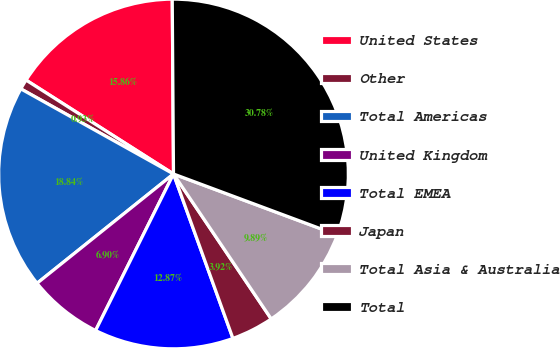Convert chart to OTSL. <chart><loc_0><loc_0><loc_500><loc_500><pie_chart><fcel>United States<fcel>Other<fcel>Total Americas<fcel>United Kingdom<fcel>Total EMEA<fcel>Japan<fcel>Total Asia & Australia<fcel>Total<nl><fcel>15.86%<fcel>0.93%<fcel>18.84%<fcel>6.9%<fcel>12.87%<fcel>3.92%<fcel>9.89%<fcel>30.78%<nl></chart> 